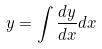<formula> <loc_0><loc_0><loc_500><loc_500>y = \int \frac { d y } { d x } d x</formula> 